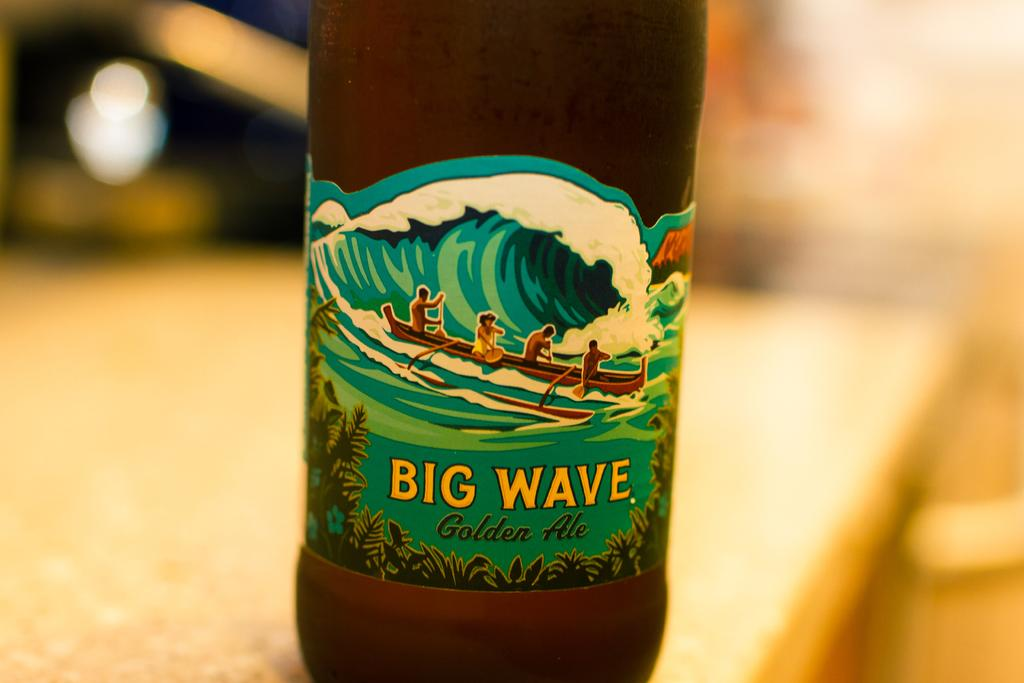<image>
Render a clear and concise summary of the photo. A bottle of Big Wave golden ale sits on a table 